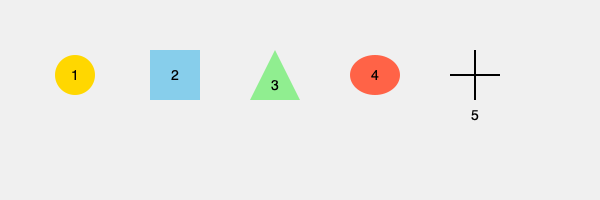Identify the correct sequence of steps in a traditional Chinese Buddhist meditation ritual, represented by the shapes above. Which order should these steps be performed? 1. The circle (1) represents the initial step of finding a quiet, comfortable place to sit and preparing the mind for meditation. This is always the first step in Buddhist meditation.

2. The square (2) symbolizes establishing a stable foundation by adopting the correct posture. In Chinese Buddhist tradition, this often involves sitting cross-legged on a cushion with a straight back.

3. The triangle (3) represents focusing on the breath and bringing attention to a single point. This step helps to calm the mind and develop concentration.

4. The oval (4) signifies expanding awareness to include bodily sensations, thoughts, and emotions. This step cultivates mindfulness and insight into the nature of experience.

5. The cross (5) represents the final stage of meditation, where the practitioner rests in a state of open awareness, free from conceptual thinking. This is often considered the culmination of the meditation practice.

In Chinese Buddhist meditation, these steps are typically followed in this specific order to gradually deepen the meditative state and cultivate wisdom and compassion.
Answer: 1-2-3-4-5 